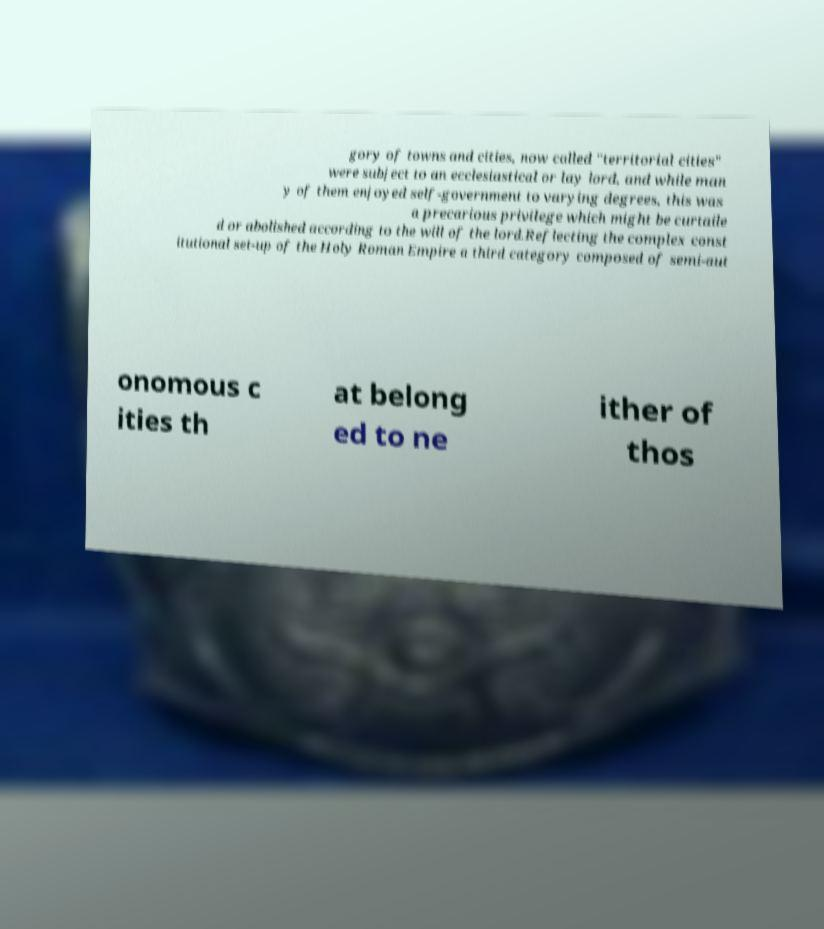Can you read and provide the text displayed in the image?This photo seems to have some interesting text. Can you extract and type it out for me? gory of towns and cities, now called "territorial cities" were subject to an ecclesiastical or lay lord, and while man y of them enjoyed self-government to varying degrees, this was a precarious privilege which might be curtaile d or abolished according to the will of the lord.Reflecting the complex const itutional set-up of the Holy Roman Empire a third category composed of semi-aut onomous c ities th at belong ed to ne ither of thos 